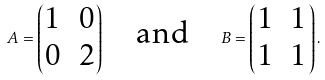Convert formula to latex. <formula><loc_0><loc_0><loc_500><loc_500>A = \begin{pmatrix} 1 & 0 \\ 0 & 2 \end{pmatrix} \quad \text {and} \quad B = \begin{pmatrix} 1 & 1 \\ 1 & 1 \end{pmatrix} .</formula> 